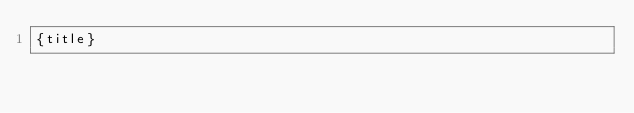Convert code to text. <code><loc_0><loc_0><loc_500><loc_500><_PHP_>{title}</code> 